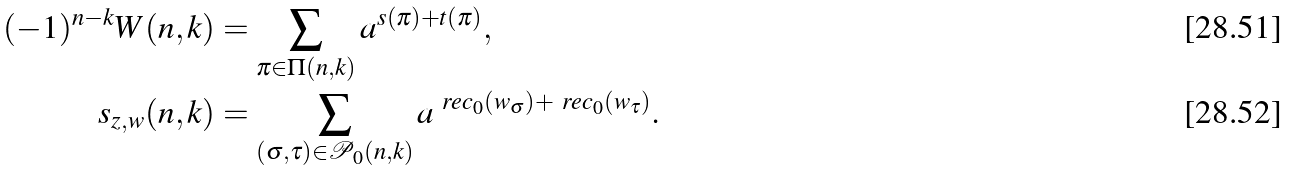Convert formula to latex. <formula><loc_0><loc_0><loc_500><loc_500>( - 1 ) ^ { n - k } W ( n , k ) & = \sum _ { \pi \in \Pi ( n , k ) } a ^ { s ( \pi ) + t ( \pi ) } , \\ s _ { z , w } ( n , k ) & = \sum _ { ( \sigma , \tau ) \in \mathcal { P } _ { 0 } ( n , k ) } a ^ { \ r e c _ { 0 } ( w _ { \sigma } ) + \ r e c _ { 0 } ( w _ { \tau } ) } .</formula> 